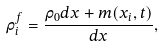Convert formula to latex. <formula><loc_0><loc_0><loc_500><loc_500>\rho _ { i } ^ { f } = \frac { \rho _ { 0 } d x + m ( x _ { i } , t ) } { d x } ,</formula> 